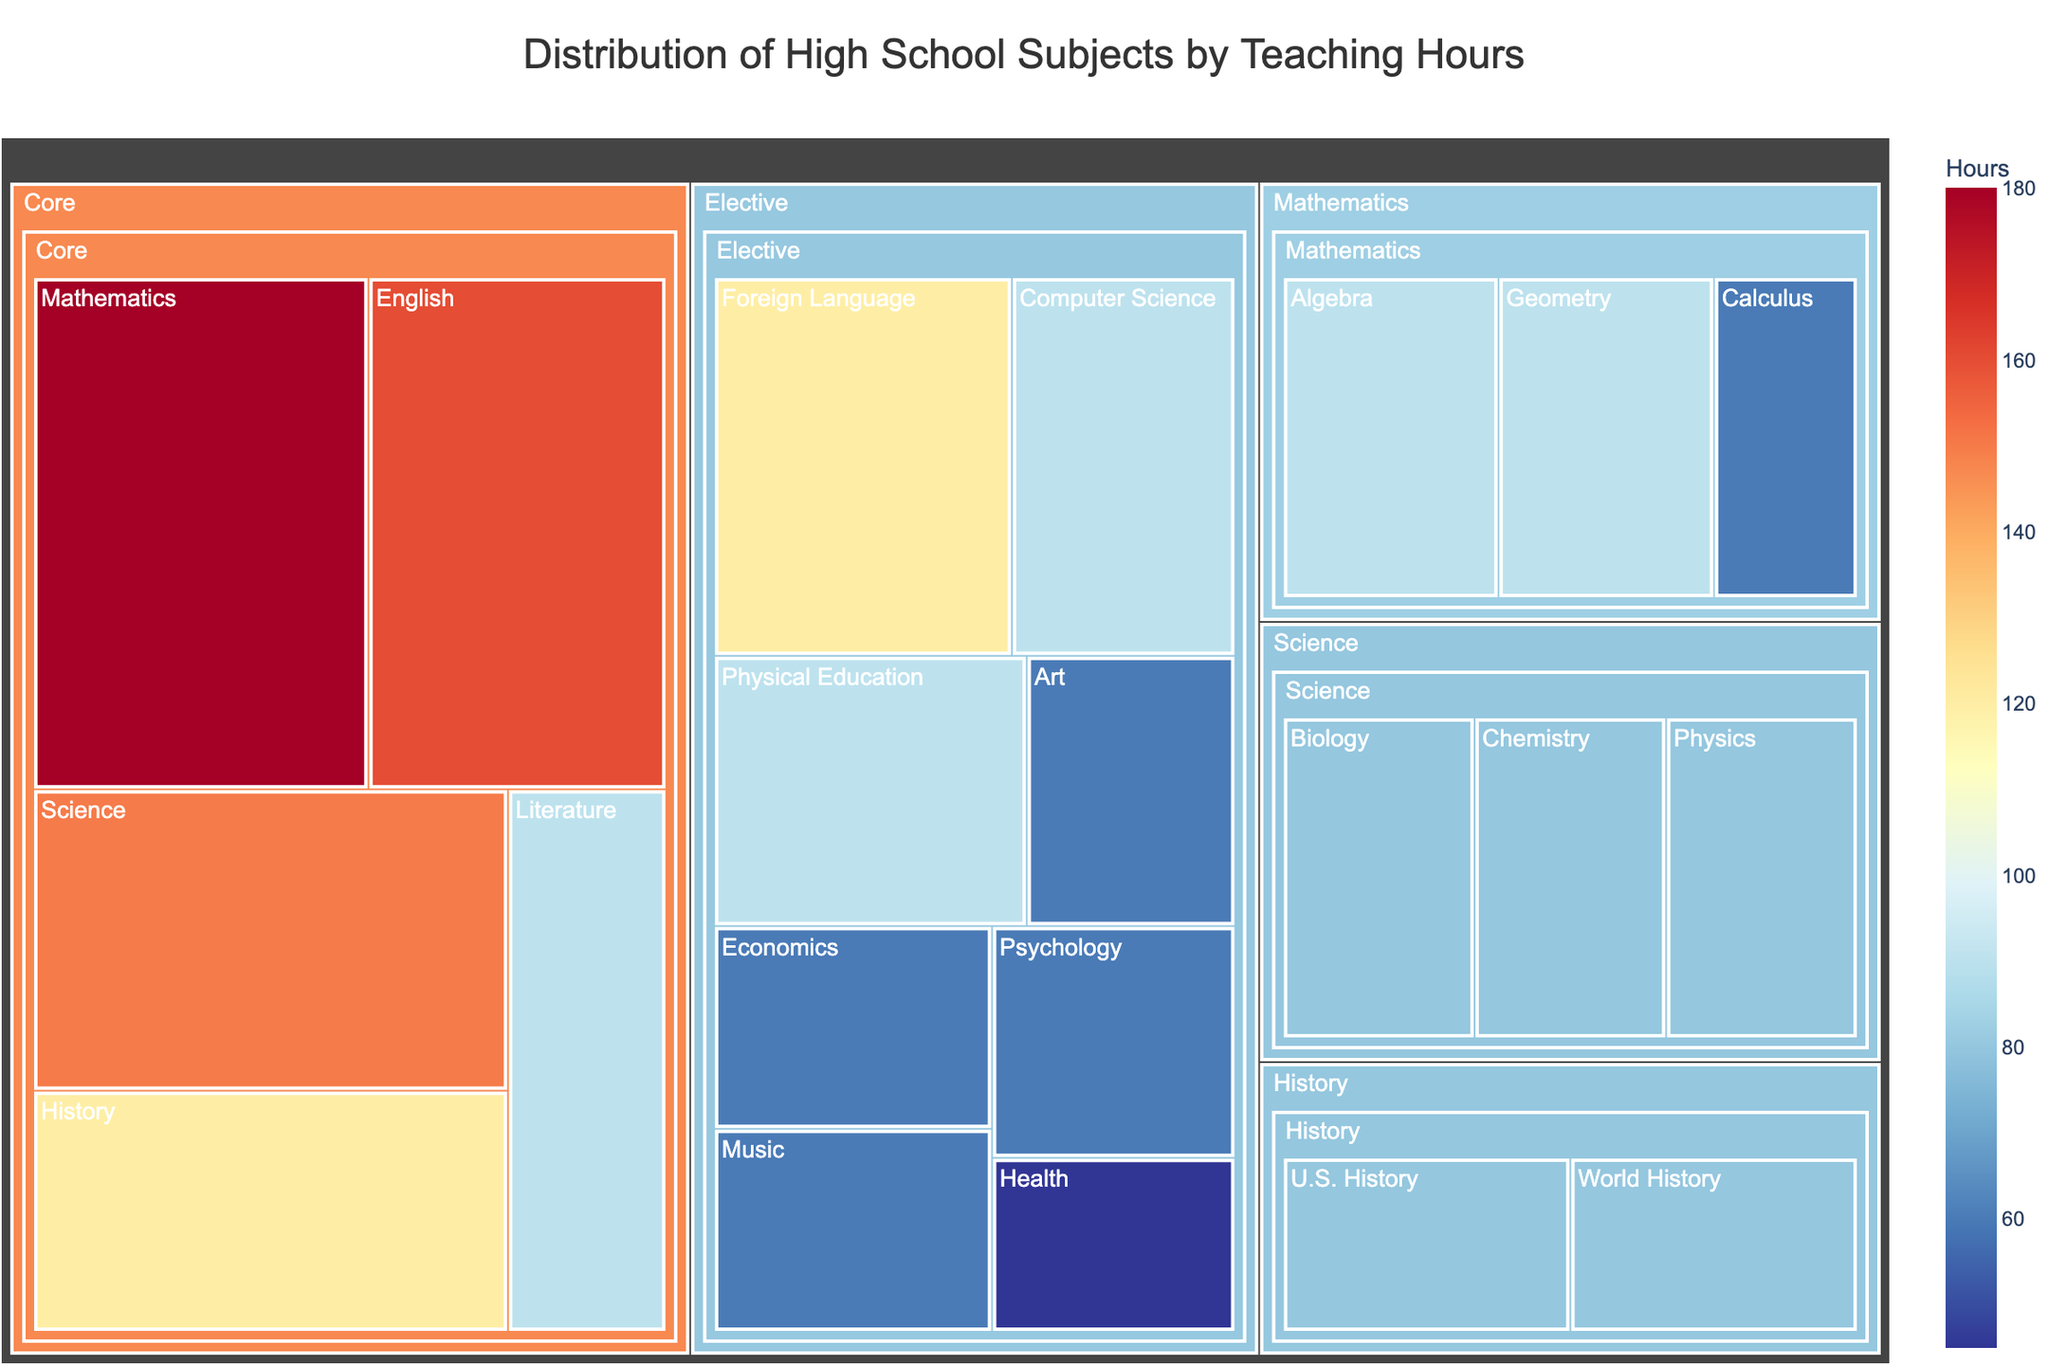What's the title of the figure? The title is prominently displayed at the top of the figure, which is typical for most plots to provide context.
Answer: Distribution of High School Subjects by Teaching Hours What subject has the highest number of teaching hours? By examining the size of the blocks in the treemap, the largest block represents the subject with the most teaching hours.
Answer: Mathematics How many hours are dedicated to core subjects? Core subjects include Mathematics, English, Science, History, and Literature. By summing their respective hours: 180 + 160 + 150 + 120 + 90 = 700
Answer: 700 Which elective subject has the fewest teaching hours? Look at the blocks labeled under Elective subjects in the treemap, and identify the smallest one.
Answer: Health Are there more hours dedicated to core subjects or elective subjects? Sum the hours of core and elective subjects separately and compare. Core: 180 + 160 + 150 + 120 + 90 = 700. Elective: 90 + 120 + 60 + 60 + 90 + 45 + 60 + 60 = 585. Core has more hours.
Answer: Core subjects What is the total number of hours dedicated to Science-related subjects? Add the hours of Science, Chemistry, Biology, and Physics: 150 + 80 + 80 + 80 = 390
Answer: 390 Which subject category has the highest average teaching hours per subject? Calculate the average for each category. Core has (180+160+150+120+90)/5 = 140, Elective has (90+120+60+60+90+45+60+60)/8 = 73.75, Science has (80+80+80)/3 = 80, Mathematics (90+90+60)/3 = 80, History (80+80)/2 = 80. Core has the highest average.
Answer: Core Is any core subject allocated the same number of hours as an elective subject? Compare the hours of core and elective subjects to find any matches. Literature (90) and Computer Science (90) are examples.
Answer: Yes Which category has the most diverse range of teaching hours among its subjects? Look at the span from the highest to the lowest hours within each category. Core range: 180-90=90, Elective range: 120-45=75, Mathematics range: 90-60=30, Science range: 80-80=0, History range: 80-80=0. Core has the greatest range.
Answer: Core How does the teaching time of U.S. History compare to World History? Compare the hours directly from the blocks representing these subjects.
Answer: They have the same hours 